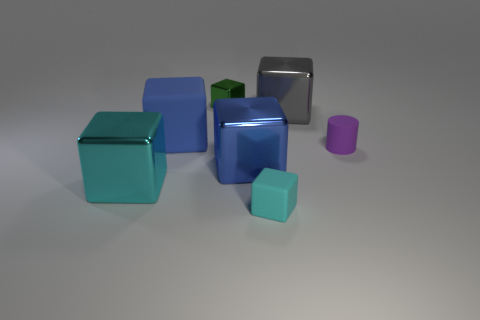Subtract all big blue cubes. How many cubes are left? 4 Add 2 big blue objects. How many objects exist? 9 Subtract all cyan cubes. How many cubes are left? 4 Subtract all brown balls. How many cyan cubes are left? 2 Subtract all blue blocks. Subtract all gray cylinders. How many blocks are left? 4 Subtract all blocks. How many objects are left? 1 Subtract 3 cubes. How many cubes are left? 3 Subtract 0 green balls. How many objects are left? 7 Subtract all small cyan cylinders. Subtract all blue cubes. How many objects are left? 5 Add 3 large gray metal objects. How many large gray metal objects are left? 4 